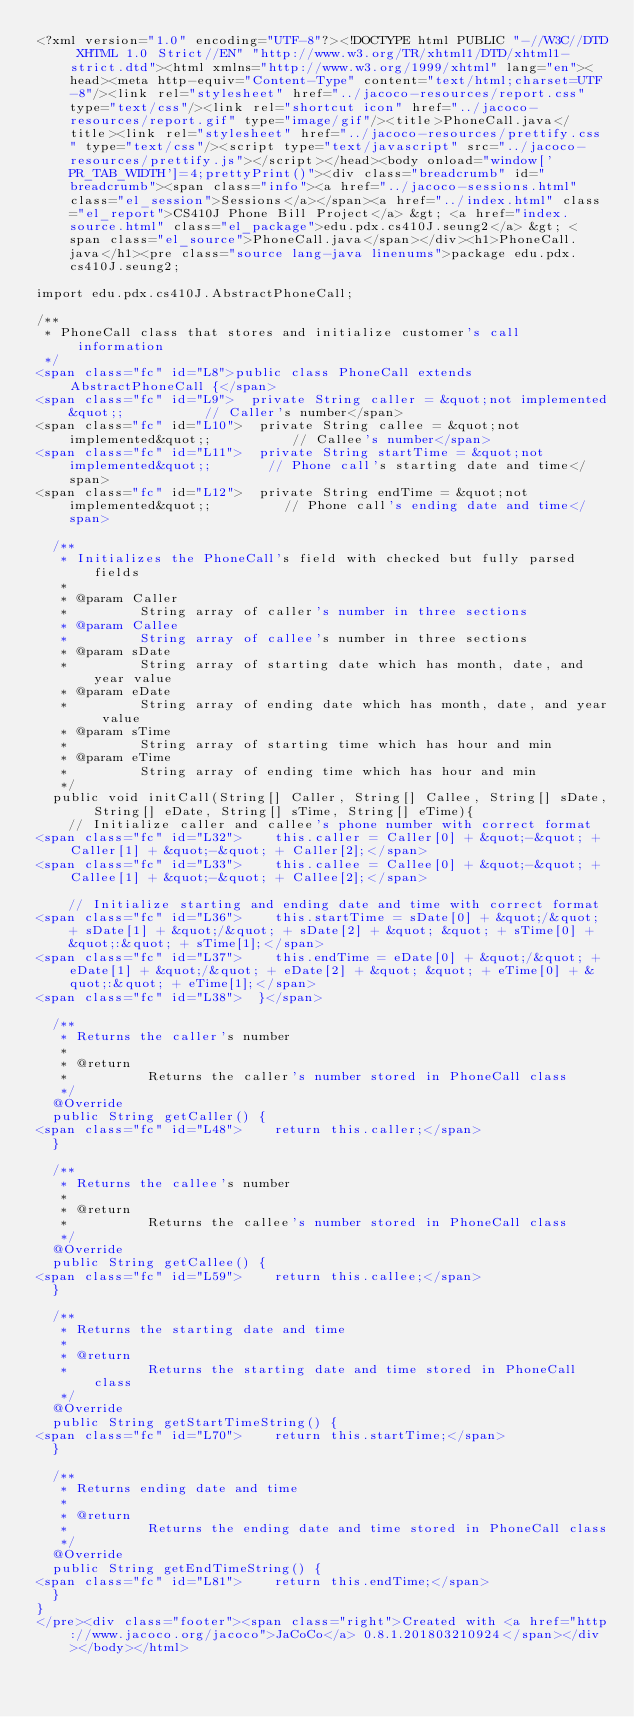Convert code to text. <code><loc_0><loc_0><loc_500><loc_500><_HTML_><?xml version="1.0" encoding="UTF-8"?><!DOCTYPE html PUBLIC "-//W3C//DTD XHTML 1.0 Strict//EN" "http://www.w3.org/TR/xhtml1/DTD/xhtml1-strict.dtd"><html xmlns="http://www.w3.org/1999/xhtml" lang="en"><head><meta http-equiv="Content-Type" content="text/html;charset=UTF-8"/><link rel="stylesheet" href="../jacoco-resources/report.css" type="text/css"/><link rel="shortcut icon" href="../jacoco-resources/report.gif" type="image/gif"/><title>PhoneCall.java</title><link rel="stylesheet" href="../jacoco-resources/prettify.css" type="text/css"/><script type="text/javascript" src="../jacoco-resources/prettify.js"></script></head><body onload="window['PR_TAB_WIDTH']=4;prettyPrint()"><div class="breadcrumb" id="breadcrumb"><span class="info"><a href="../jacoco-sessions.html" class="el_session">Sessions</a></span><a href="../index.html" class="el_report">CS410J Phone Bill Project</a> &gt; <a href="index.source.html" class="el_package">edu.pdx.cs410J.seung2</a> &gt; <span class="el_source">PhoneCall.java</span></div><h1>PhoneCall.java</h1><pre class="source lang-java linenums">package edu.pdx.cs410J.seung2;

import edu.pdx.cs410J.AbstractPhoneCall;

/**
 * PhoneCall class that stores and initialize customer's call information
 */
<span class="fc" id="L8">public class PhoneCall extends AbstractPhoneCall {</span>
<span class="fc" id="L9">  private String caller = &quot;not implemented&quot;;          // Caller's number</span>
<span class="fc" id="L10">  private String callee = &quot;not implemented&quot;;          // Callee's number</span>
<span class="fc" id="L11">  private String startTime = &quot;not implemented&quot;;       // Phone call's starting date and time</span>
<span class="fc" id="L12">  private String endTime = &quot;not implemented&quot;;         // Phone call's ending date and time</span>

  /**
   * Initializes the PhoneCall's field with checked but fully parsed fields
   *
   * @param Caller
   *         String array of caller's number in three sections
   * @param Callee
   *         String array of callee's number in three sections
   * @param sDate
   *         String array of starting date which has month, date, and year value
   * @param eDate
   *         String array of ending date which has month, date, and year value
   * @param sTime
   *         String array of starting time which has hour and min
   * @param eTime
   *         String array of ending time which has hour and min
   */
  public void initCall(String[] Caller, String[] Callee, String[] sDate, String[] eDate, String[] sTime, String[] eTime){
    // Initialize caller and callee's phone number with correct format
<span class="fc" id="L32">    this.caller = Caller[0] + &quot;-&quot; + Caller[1] + &quot;-&quot; + Caller[2];</span>
<span class="fc" id="L33">    this.callee = Callee[0] + &quot;-&quot; + Callee[1] + &quot;-&quot; + Callee[2];</span>

    // Initialize starting and ending date and time with correct format
<span class="fc" id="L36">    this.startTime = sDate[0] + &quot;/&quot; + sDate[1] + &quot;/&quot; + sDate[2] + &quot; &quot; + sTime[0] + &quot;:&quot; + sTime[1];</span>
<span class="fc" id="L37">    this.endTime = eDate[0] + &quot;/&quot; + eDate[1] + &quot;/&quot; + eDate[2] + &quot; &quot; + eTime[0] + &quot;:&quot; + eTime[1];</span>
<span class="fc" id="L38">  }</span>

  /**
   * Returns the caller's number
   *
   * @return
   *          Returns the caller's number stored in PhoneCall class
   */
  @Override
  public String getCaller() {
<span class="fc" id="L48">    return this.caller;</span>
  }

  /**
   * Returns the callee's number
   *
   * @return
   *          Returns the callee's number stored in PhoneCall class
   */
  @Override
  public String getCallee() {
<span class="fc" id="L59">    return this.callee;</span>
  }

  /**
   * Returns the starting date and time
   *
   * @return
   *          Returns the starting date and time stored in PhoneCall class
   */
  @Override
  public String getStartTimeString() {
<span class="fc" id="L70">    return this.startTime;</span>
  }

  /**
   * Returns ending date and time
   *
   * @return
   *          Returns the ending date and time stored in PhoneCall class
   */
  @Override
  public String getEndTimeString() {
<span class="fc" id="L81">    return this.endTime;</span>
  }
}
</pre><div class="footer"><span class="right">Created with <a href="http://www.jacoco.org/jacoco">JaCoCo</a> 0.8.1.201803210924</span></div></body></html></code> 